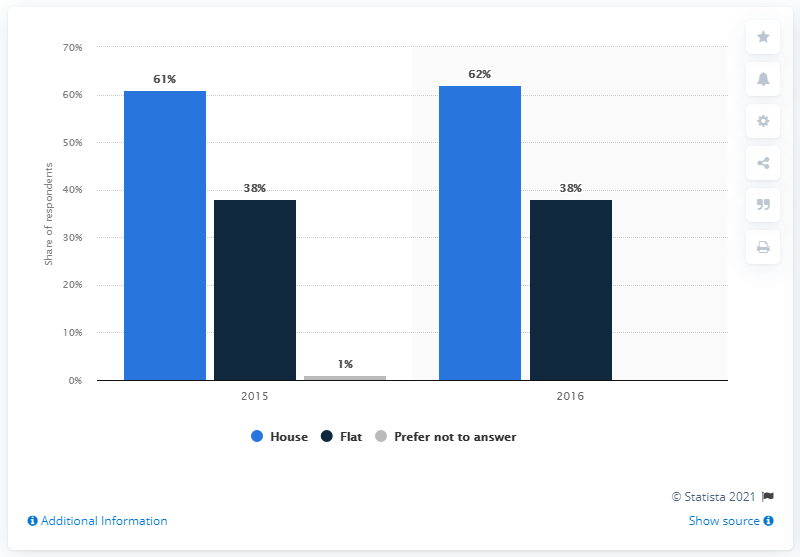List a handful of essential elements in this visual. In 2015, the label with the highest value was "House". As of 2016, the average percentage of people living in flats in France was 38%. In 2016, the term 'house' and 'flat' can refer to different types of residential buildings. The term 'house' typically refers to a free-standing, detached residential building, while 'flat' refers to a self-contained unit within a larger building, such as an apartment or a townhouse. 